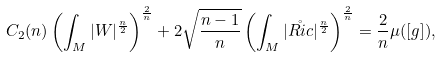<formula> <loc_0><loc_0><loc_500><loc_500>C _ { 2 } ( n ) \left ( \int _ { M } | W | ^ { \frac { n } { 2 } } \right ) ^ { \frac { 2 } { n } } + 2 \sqrt { \frac { n - 1 } { n } } \left ( \int _ { M } | \mathring { R i c } | ^ { \frac { n } { 2 } } \right ) ^ { \frac { 2 } { n } } = \frac { 2 } { n } \mu ( [ g ] ) ,</formula> 